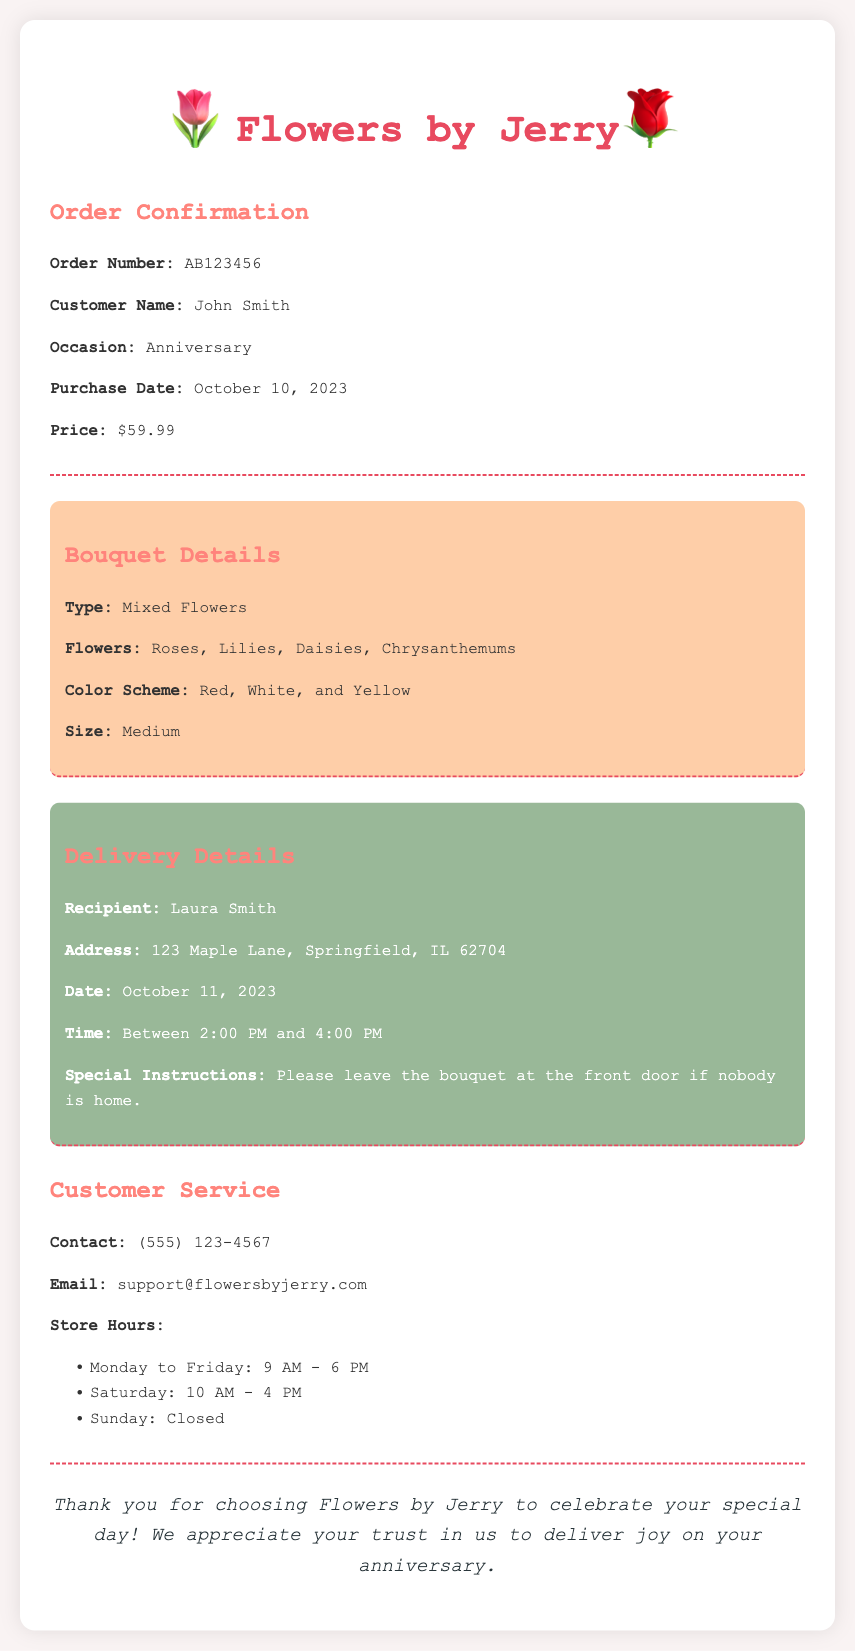What is the order number? The order number is stated in the confirmation section of the document.
Answer: AB123456 Who is the recipient of the bouquet? The recipient's name is given in the delivery details section.
Answer: Laura Smith What is the delivery date? The delivery date is specified in the delivery details section.
Answer: October 11, 2023 What flowers are included in the bouquet? The types of flowers are listed in the bouquet details section.
Answer: Roses, Lilies, Daisies, Chrysanthemums What special instructions were noted for delivery? Special instructions for delivery are detailed in the delivery info section.
Answer: Please leave the bouquet at the front door if nobody is home What is the price of the bouquet? The price is mentioned in the order confirmation section.
Answer: $59.99 On what date was the order purchased? The purchase date is indicated in the order confirmation section.
Answer: October 10, 2023 What time will the delivery take place? The time for the delivery is outlined in the delivery details section.
Answer: Between 2:00 PM and 4:00 PM What are the customer service contact details? Customer service contact information is enumerated in the customer service section.
Answer: (555) 123-4567 What occasion is this bouquet for? The occasion is specified in the order confirmation section.
Answer: Anniversary 